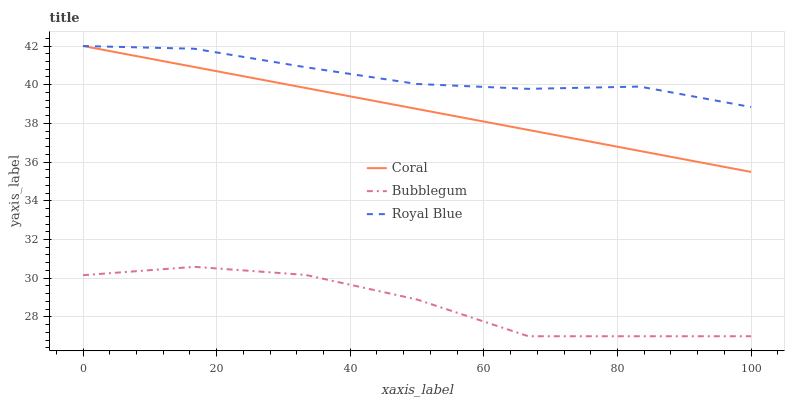Does Bubblegum have the minimum area under the curve?
Answer yes or no. Yes. Does Royal Blue have the maximum area under the curve?
Answer yes or no. Yes. Does Coral have the minimum area under the curve?
Answer yes or no. No. Does Coral have the maximum area under the curve?
Answer yes or no. No. Is Coral the smoothest?
Answer yes or no. Yes. Is Bubblegum the roughest?
Answer yes or no. Yes. Is Bubblegum the smoothest?
Answer yes or no. No. Is Coral the roughest?
Answer yes or no. No. Does Bubblegum have the lowest value?
Answer yes or no. Yes. Does Coral have the lowest value?
Answer yes or no. No. Does Coral have the highest value?
Answer yes or no. Yes. Does Bubblegum have the highest value?
Answer yes or no. No. Is Bubblegum less than Coral?
Answer yes or no. Yes. Is Coral greater than Bubblegum?
Answer yes or no. Yes. Does Coral intersect Royal Blue?
Answer yes or no. Yes. Is Coral less than Royal Blue?
Answer yes or no. No. Is Coral greater than Royal Blue?
Answer yes or no. No. Does Bubblegum intersect Coral?
Answer yes or no. No. 